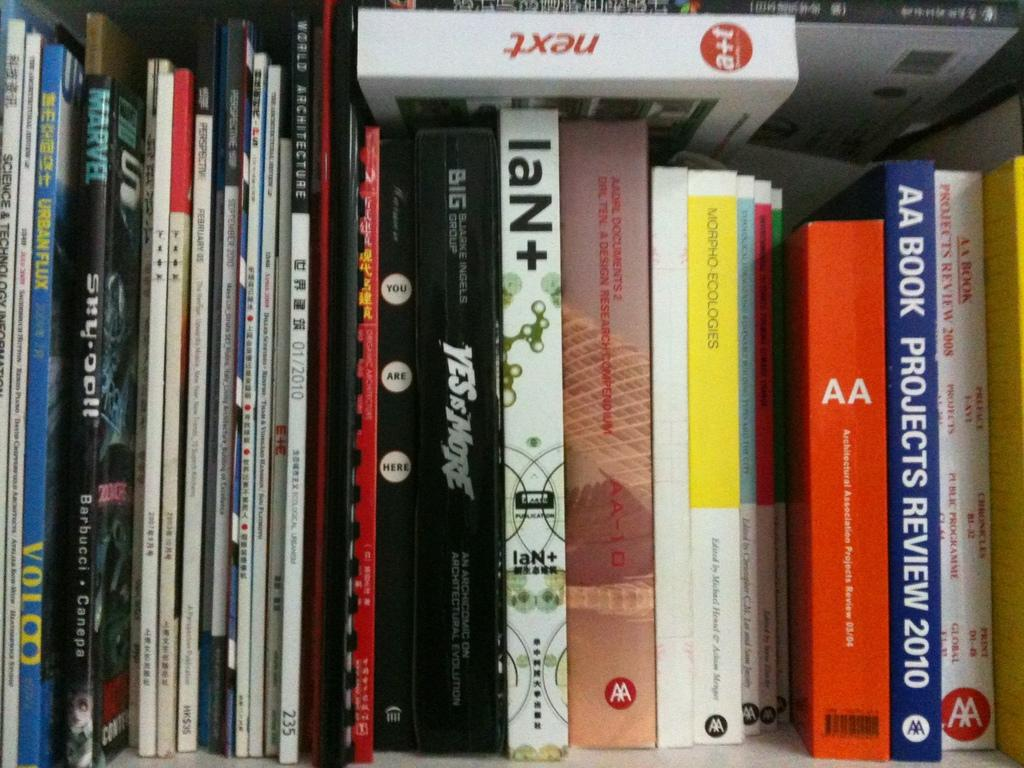What objects can be seen in the image? There are books in the image. Where are the books located? The books are in a rack. What type of dock can be seen near the books in the image? There is no dock present in the image; it only features books in a rack. 